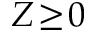Convert formula to latex. <formula><loc_0><loc_0><loc_500><loc_500>Z \, \geq \, 0</formula> 